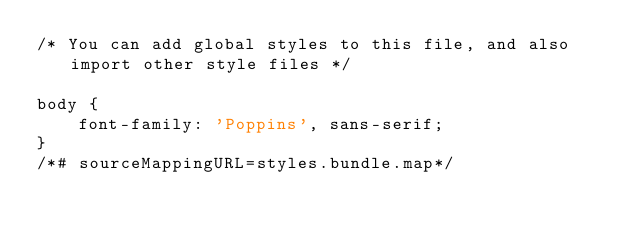Convert code to text. <code><loc_0><loc_0><loc_500><loc_500><_CSS_>/* You can add global styles to this file, and also import other style files */

body {
    font-family: 'Poppins', sans-serif;
}
/*# sourceMappingURL=styles.bundle.map*/</code> 